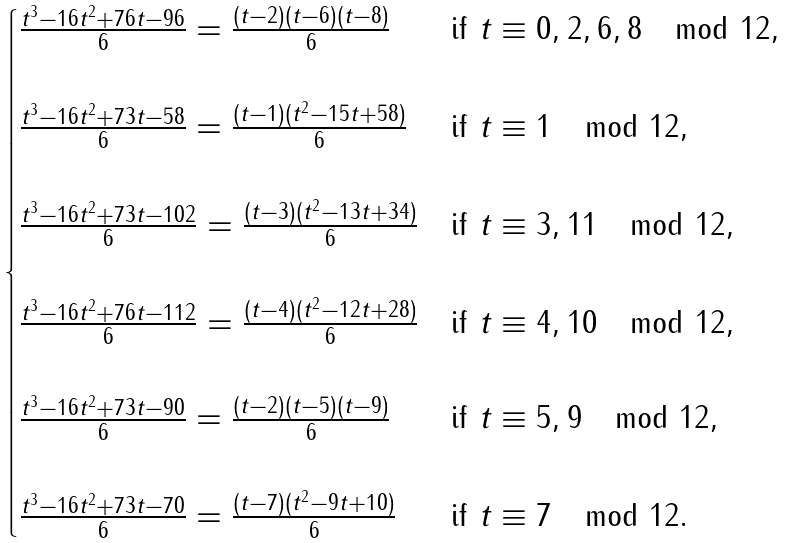<formula> <loc_0><loc_0><loc_500><loc_500>\begin{cases} \frac { t ^ { 3 } - 1 6 t ^ { 2 } + 7 6 t - 9 6 } { 6 } = \frac { ( t - 2 ) ( t - 6 ) ( t - 8 ) } { 6 } & \text {if } t \equiv 0 , 2 , 6 , 8 \mod 1 2 , \\ \\ \frac { t ^ { 3 } - 1 6 t ^ { 2 } + 7 3 t - 5 8 } { 6 } = \frac { ( t - 1 ) ( t ^ { 2 } - 1 5 t + 5 8 ) } { 6 } & \text {if } t \equiv 1 \mod 1 2 , \\ \\ \frac { t ^ { 3 } - 1 6 t ^ { 2 } + 7 3 t - 1 0 2 } { 6 } = \frac { ( t - 3 ) ( t ^ { 2 } - 1 3 t + 3 4 ) } { 6 } & \text {if } t \equiv 3 , 1 1 \mod 1 2 , \\ \\ \frac { t ^ { 3 } - 1 6 t ^ { 2 } + 7 6 t - 1 1 2 } { 6 } = \frac { ( t - 4 ) ( t ^ { 2 } - 1 2 t + 2 8 ) } { 6 } & \text {if } t \equiv 4 , 1 0 \mod 1 2 , \\ \\ \frac { t ^ { 3 } - 1 6 t ^ { 2 } + 7 3 t - 9 0 } { 6 } = \frac { ( t - 2 ) ( t - 5 ) ( t - 9 ) } { 6 } & \text {if } t \equiv 5 , 9 \mod 1 2 , \\ \\ \frac { t ^ { 3 } - 1 6 t ^ { 2 } + 7 3 t - 7 0 } { 6 } = \frac { ( t - 7 ) ( t ^ { 2 } - 9 t + 1 0 ) } { 6 } & \text {if } t \equiv 7 \mod 1 2 . \end{cases}</formula> 